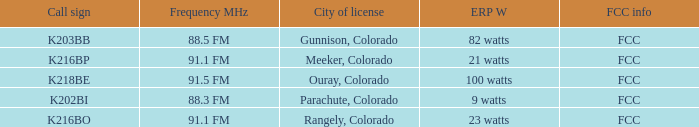5 fm? 82 watts. 